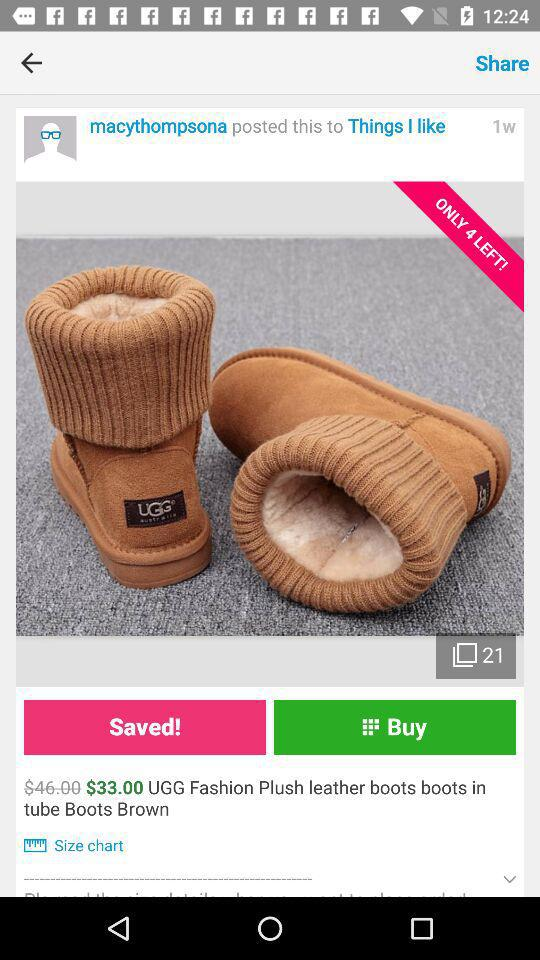When was the post posted? The post was posted 1 week ago. 